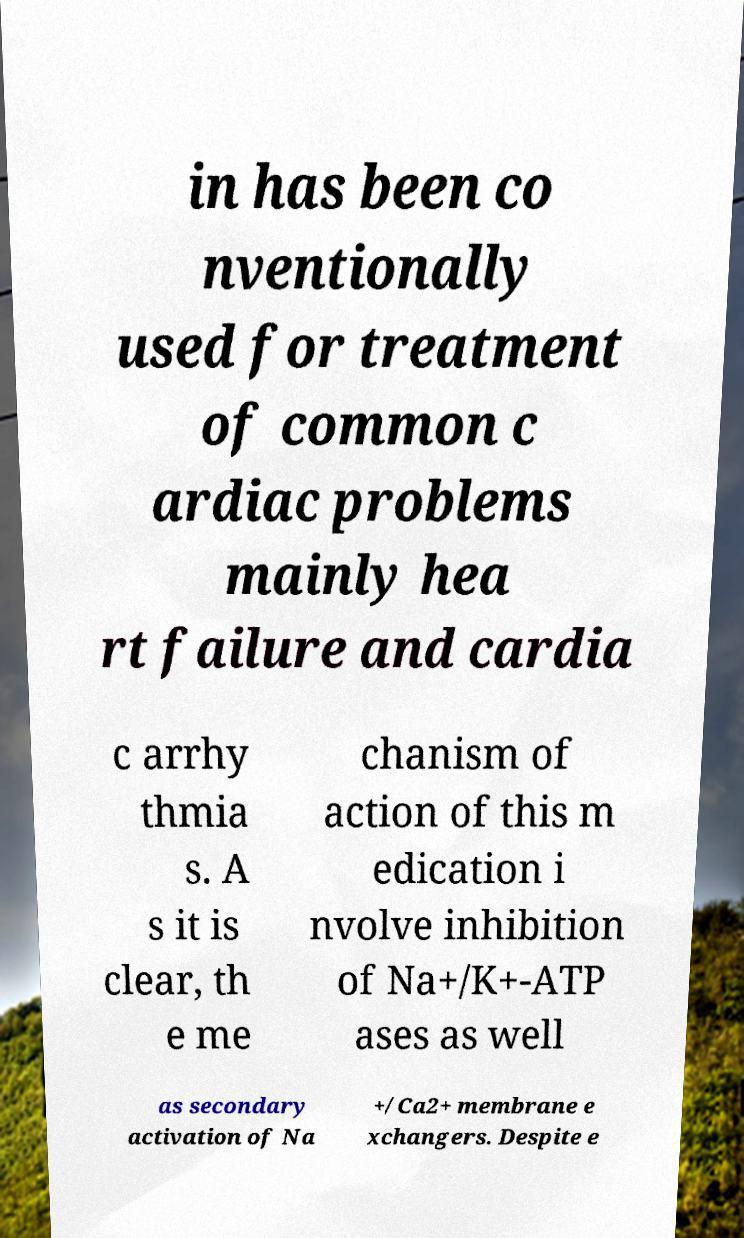Can you read and provide the text displayed in the image?This photo seems to have some interesting text. Can you extract and type it out for me? in has been co nventionally used for treatment of common c ardiac problems mainly hea rt failure and cardia c arrhy thmia s. A s it is clear, th e me chanism of action of this m edication i nvolve inhibition of Na+/K+-ATP ases as well as secondary activation of Na +/Ca2+ membrane e xchangers. Despite e 